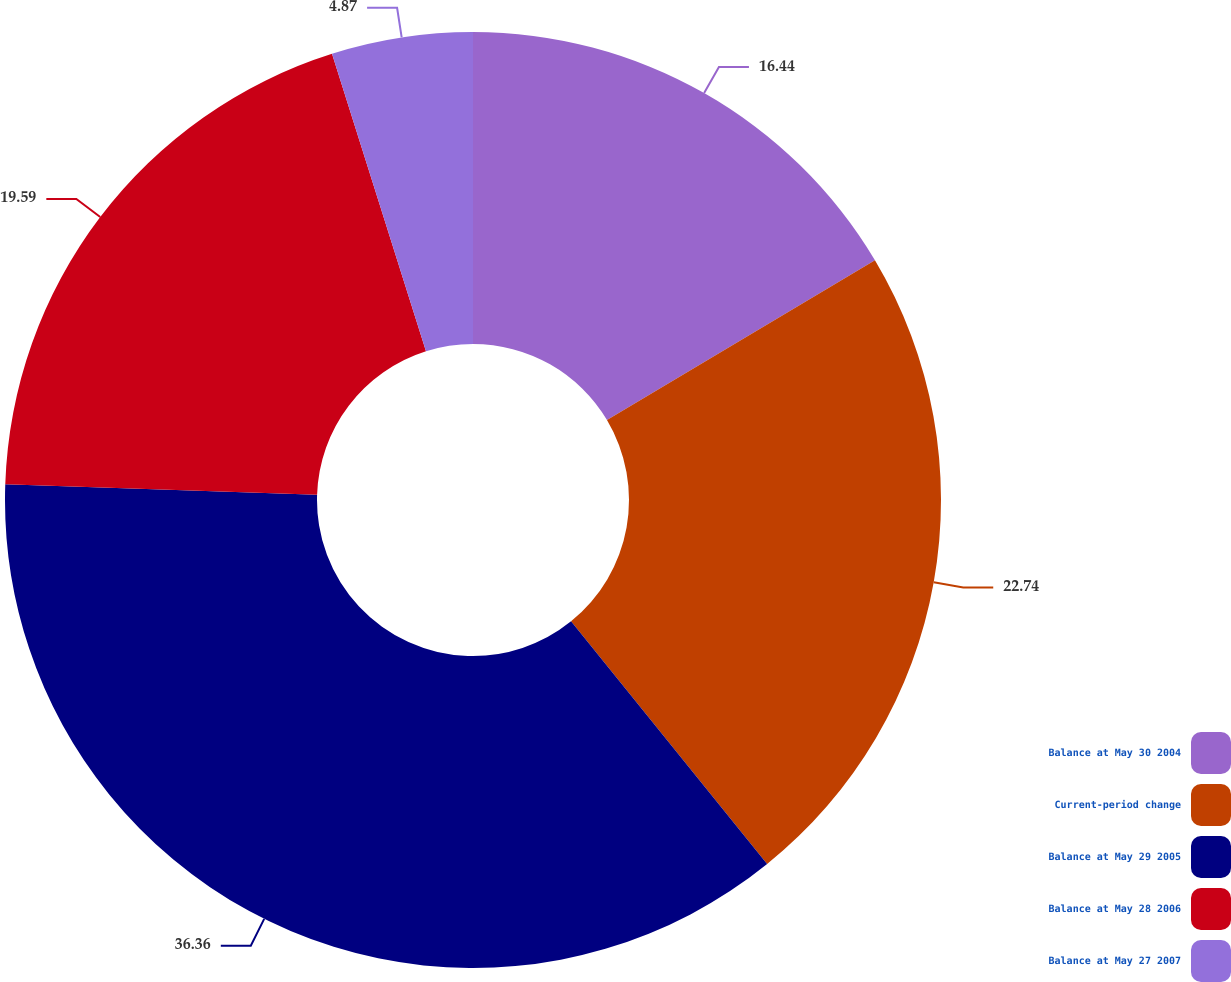Convert chart to OTSL. <chart><loc_0><loc_0><loc_500><loc_500><pie_chart><fcel>Balance at May 30 2004<fcel>Current-period change<fcel>Balance at May 29 2005<fcel>Balance at May 28 2006<fcel>Balance at May 27 2007<nl><fcel>16.44%<fcel>22.74%<fcel>36.35%<fcel>19.59%<fcel>4.87%<nl></chart> 